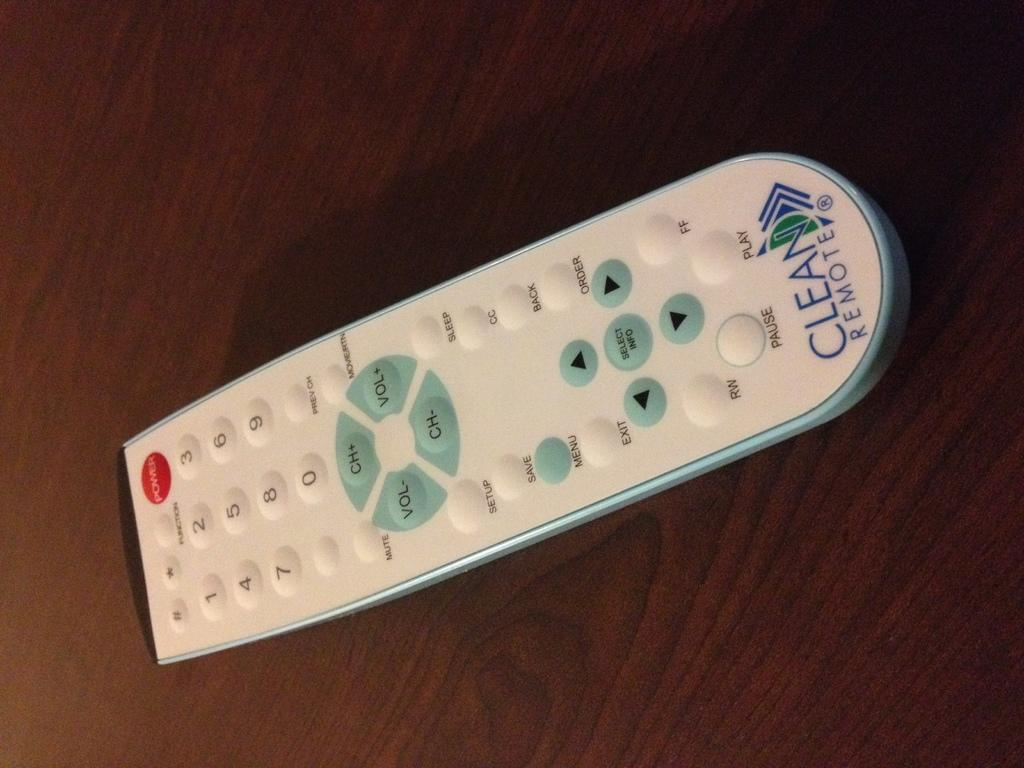<image>
Write a terse but informative summary of the picture. a remote that says 'clean remote' on the bottom of it 